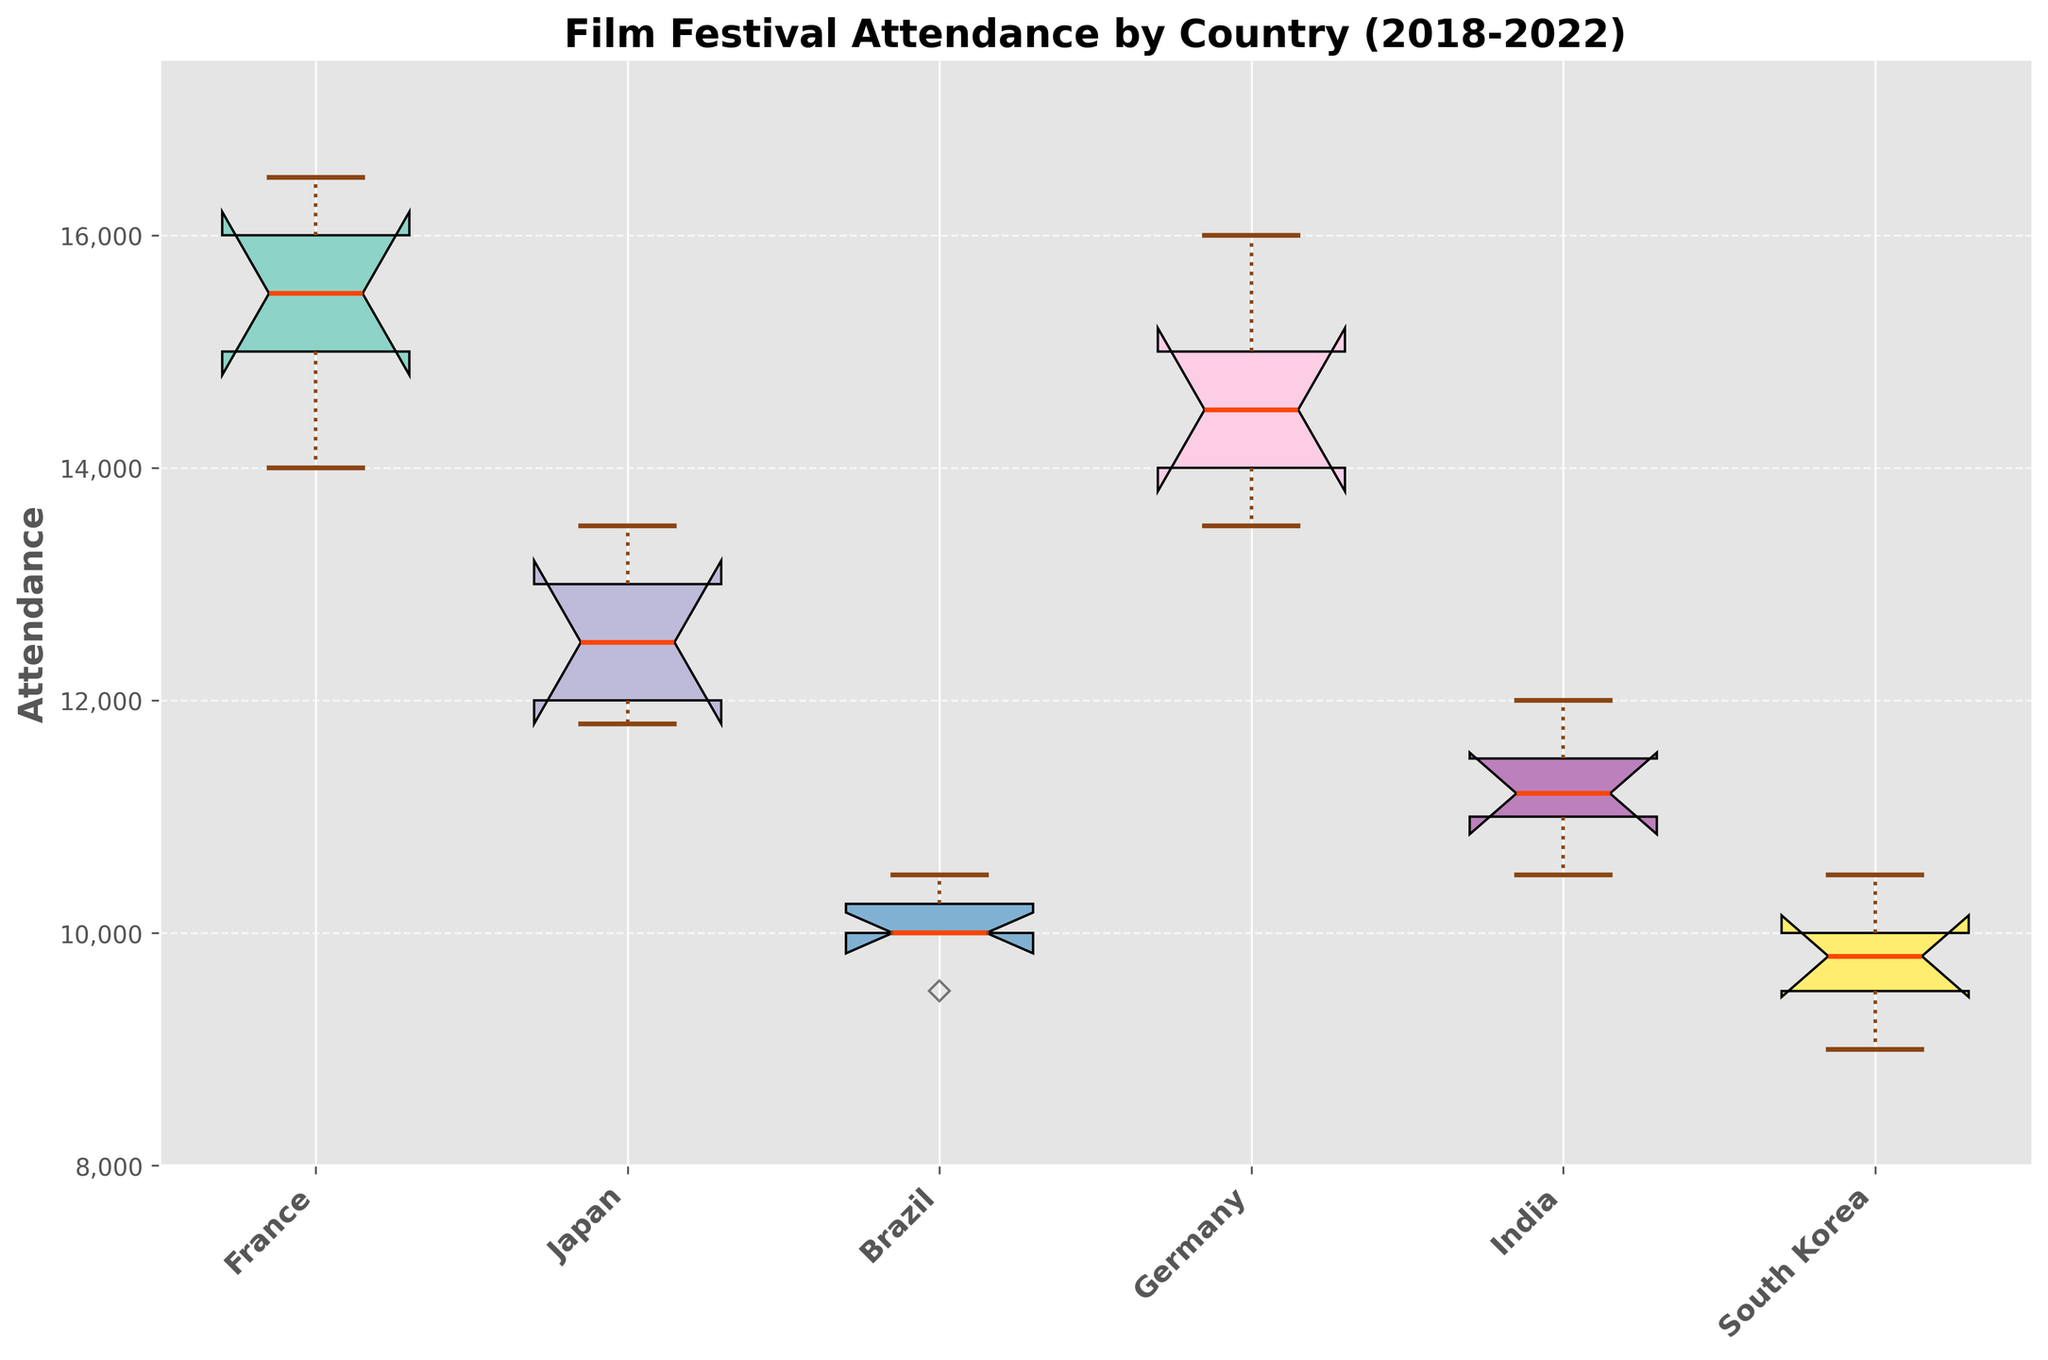What is the title of the figure? The title is located at the top center of the figure and states the main topic of the visualization.
Answer: Film Festival Attendance by Country (2018-2022) What is the range of attendance values shown on the y-axis? The y-axis shows the range of attendance values, which is explicitly indicated from the bottom to the top of the axis.
Answer: 8000 to 17500 Which country shows the highest median attendance? To determine the highest median attendance, look at the bold line inside each box representing the median value. The highest among these lines will indicate the country with the highest median.
Answer: Germany Which country shows the most variation in attendance? Variation in attendance can be inferred from the length of each box and the length of the whiskers—the longer they are, the more variation there is.
Answer: France What is the median attendance for Japan? Identify the bold line within Japan's box. The value corresponding to this line on the y-axis is the median attendance for Japan.
Answer: 12500 Which country had the least increase in attendance over the years? The least increase can be assessed by observing the boxes and whiskers for each country. Look for the box with the smallest increase or least movement upwards.
Answer: Brazil Do any countries have outliers and, if so, which ones? Outliers in box plots are shown as individual points outside the whiskers. Identify which countries have such points visible.
Answer: None What color represents India in the box plot? Boxes are colored with distinct colors, and by matching the color with India’s box, the specific color used is identified.
Answer: A shade from the Set3 color palette Which country shows the least variation in attendance? Identify the country with the shortest box (small interquartile range) and whiskers, indicating the least variation.
Answer: South Korea What is the difference between the maximum and minimum attendance values for France? The maximum value is at the top whisker, and the minimum at the bottom whisker. Subtract the minimum value from the maximum value using these visual points.
Answer: 2500 